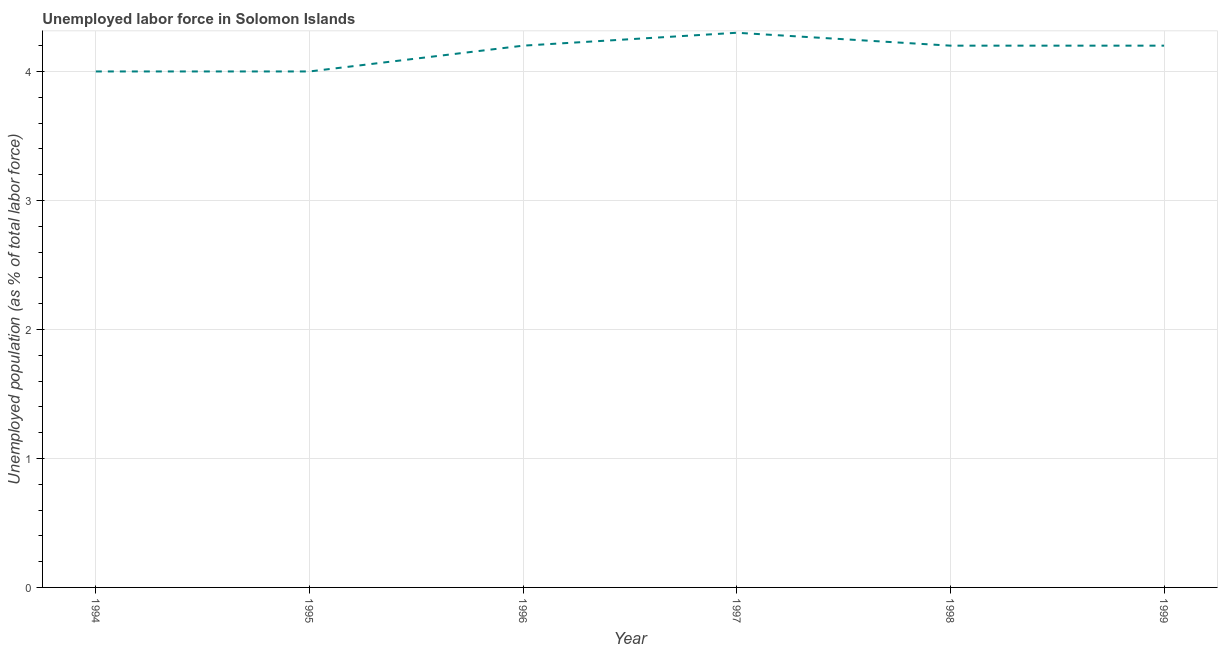Across all years, what is the maximum total unemployed population?
Keep it short and to the point. 4.3. Across all years, what is the minimum total unemployed population?
Give a very brief answer. 4. What is the sum of the total unemployed population?
Offer a terse response. 24.9. What is the difference between the total unemployed population in 1995 and 1996?
Give a very brief answer. -0.2. What is the average total unemployed population per year?
Your answer should be very brief. 4.15. What is the median total unemployed population?
Your answer should be very brief. 4.2. Do a majority of the years between 1999 and 1997 (inclusive) have total unemployed population greater than 2.4 %?
Your response must be concise. No. What is the ratio of the total unemployed population in 1995 to that in 1998?
Keep it short and to the point. 0.95. Is the total unemployed population in 1996 less than that in 1999?
Offer a very short reply. No. Is the difference between the total unemployed population in 1996 and 1997 greater than the difference between any two years?
Your response must be concise. No. What is the difference between the highest and the second highest total unemployed population?
Provide a short and direct response. 0.1. What is the difference between the highest and the lowest total unemployed population?
Your answer should be compact. 0.3. In how many years, is the total unemployed population greater than the average total unemployed population taken over all years?
Provide a short and direct response. 4. Does the total unemployed population monotonically increase over the years?
Ensure brevity in your answer.  No. How many years are there in the graph?
Keep it short and to the point. 6. Are the values on the major ticks of Y-axis written in scientific E-notation?
Provide a short and direct response. No. What is the title of the graph?
Keep it short and to the point. Unemployed labor force in Solomon Islands. What is the label or title of the Y-axis?
Offer a terse response. Unemployed population (as % of total labor force). What is the Unemployed population (as % of total labor force) in 1994?
Offer a terse response. 4. What is the Unemployed population (as % of total labor force) in 1995?
Provide a short and direct response. 4. What is the Unemployed population (as % of total labor force) of 1996?
Offer a terse response. 4.2. What is the Unemployed population (as % of total labor force) of 1997?
Your response must be concise. 4.3. What is the Unemployed population (as % of total labor force) of 1998?
Offer a very short reply. 4.2. What is the Unemployed population (as % of total labor force) in 1999?
Provide a short and direct response. 4.2. What is the difference between the Unemployed population (as % of total labor force) in 1994 and 1998?
Keep it short and to the point. -0.2. What is the difference between the Unemployed population (as % of total labor force) in 1995 and 1997?
Make the answer very short. -0.3. What is the difference between the Unemployed population (as % of total labor force) in 1995 and 1999?
Provide a succinct answer. -0.2. What is the difference between the Unemployed population (as % of total labor force) in 1996 and 1997?
Offer a very short reply. -0.1. What is the difference between the Unemployed population (as % of total labor force) in 1997 and 1999?
Give a very brief answer. 0.1. What is the ratio of the Unemployed population (as % of total labor force) in 1994 to that in 1995?
Offer a very short reply. 1. What is the ratio of the Unemployed population (as % of total labor force) in 1994 to that in 1999?
Provide a succinct answer. 0.95. What is the ratio of the Unemployed population (as % of total labor force) in 1996 to that in 1998?
Make the answer very short. 1. What is the ratio of the Unemployed population (as % of total labor force) in 1997 to that in 1998?
Offer a very short reply. 1.02. What is the ratio of the Unemployed population (as % of total labor force) in 1998 to that in 1999?
Ensure brevity in your answer.  1. 